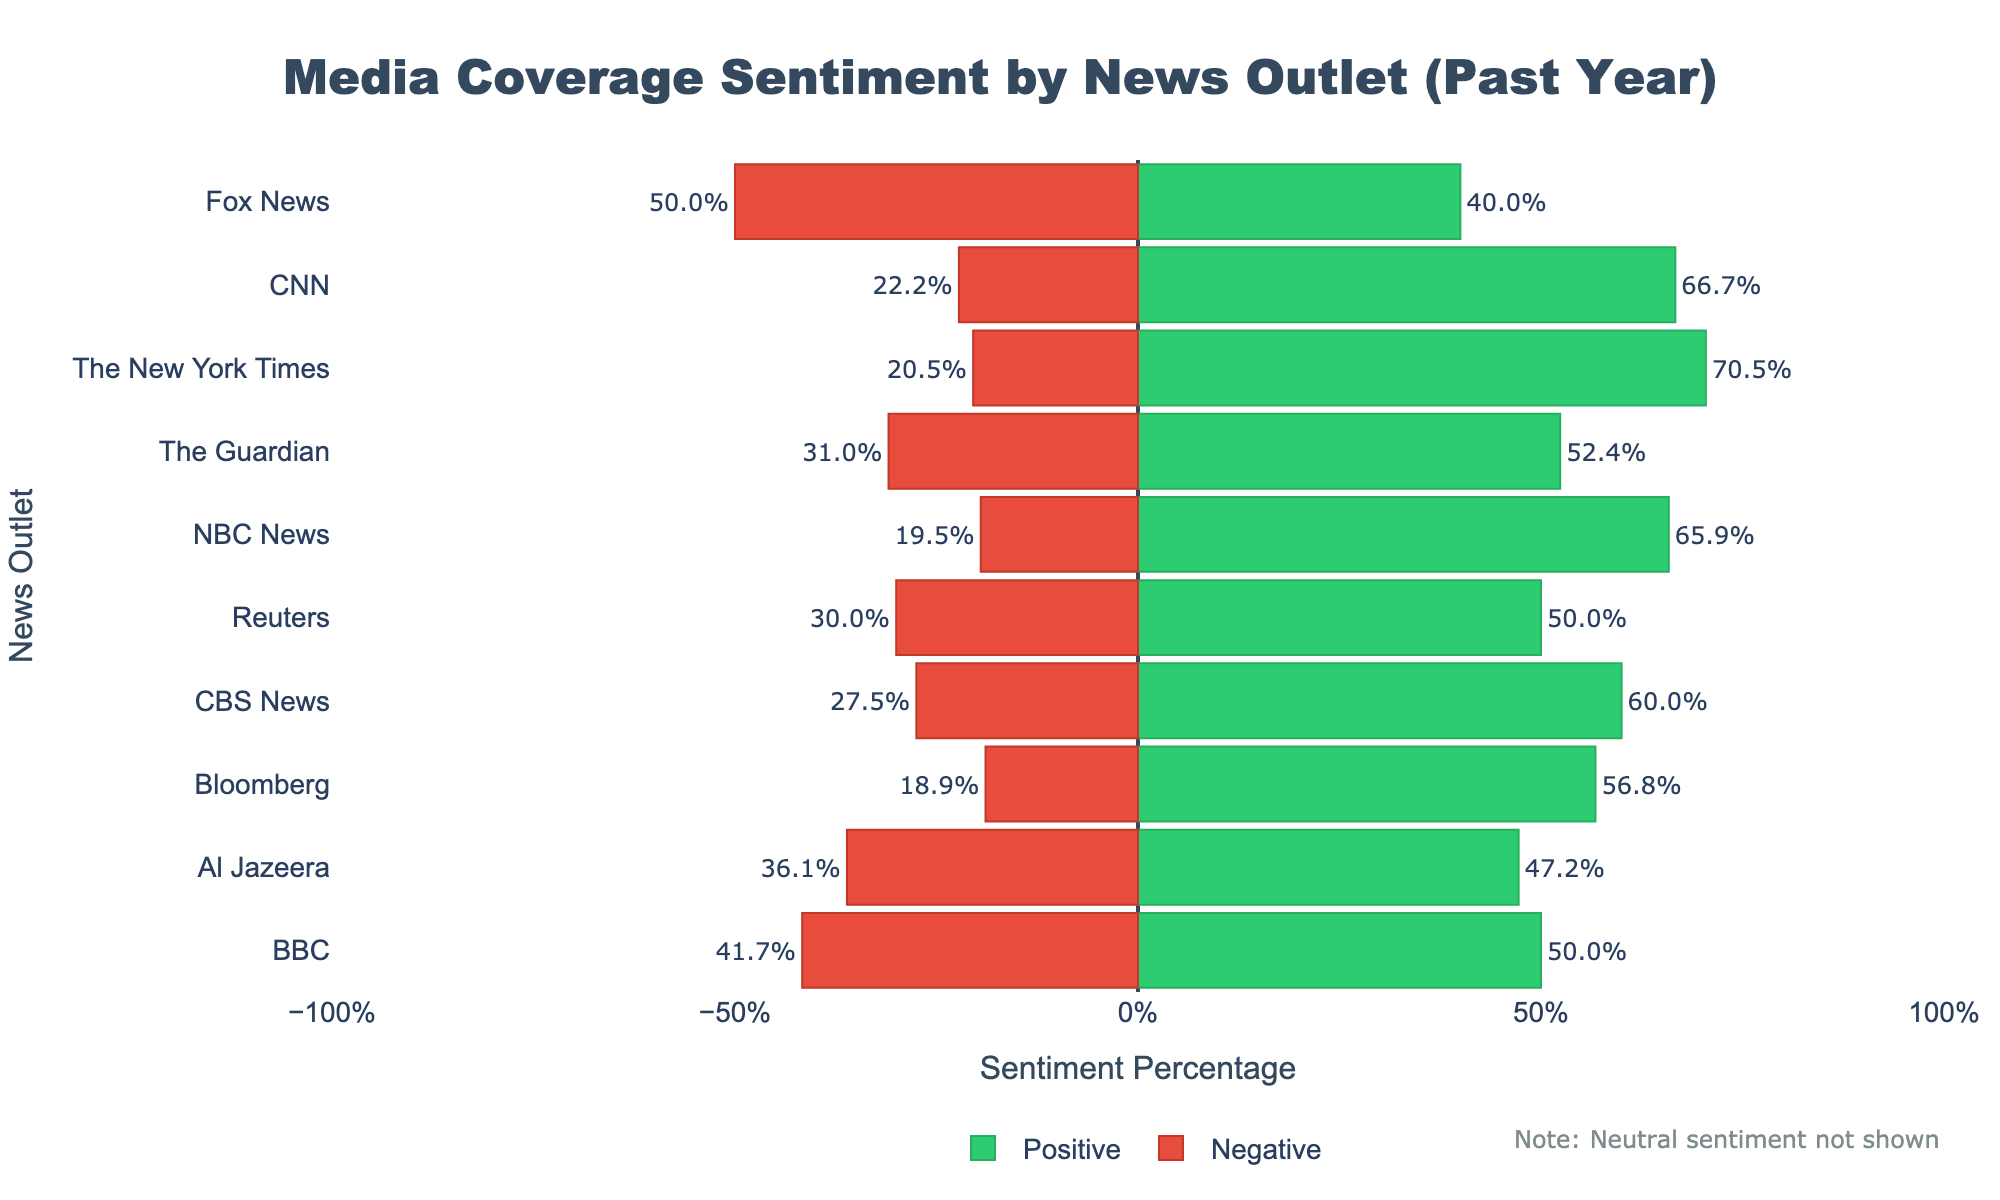Which news outlet has the highest percentage of positive mentions? By observing the bar lengths colored in green, The New York Times has the longest green bar representing the highest percentage of positive mentions.
Answer: The New York Times Which news outlet has the highest percentage of negative mentions? By comparing the lengths of the red bars, Fox News has the longest red bar representing the highest percentage of negative mentions.
Answer: Fox News What is the difference in positive sentiment percentage between The New York Times and Fox News? The positive percentage for The New York Times is read from the chart as ~67.4%, and for Fox News, it is ~40.0%. The difference is 67.4% - 40.0% = 27.4%.
Answer: 27.4% Which news outlet has the smallest difference between positive and negative sentiment percentages? By estimating the lengths of green and red bars together, we see that BBC's bars are almost equal in length. Their difference in percentages is very small compared to other outlets.
Answer: BBC How many outlets have a negative sentiment percentage greater than 50%? Reviewing the figure, only Fox News has a red bar (negative percentage) extending beyond the midpoint (50% mark). Therefore, only one outlet has a negative sentiment percentage over 50%.
Answer: 1 Compare the positive sentiment for Bloomberg and NBC News. Which one is greater and by how much? Bloomberg's positive sentiment percentage is ~60%, while NBC News's percentage is ~77.1%. The difference is ~77.1% - ~60% = ~17.1%.
Answer: NBC News by ~17.1% Which two news outlets have the closest positive sentiment percentages? By observing the green bar lengths visually, CNN (with ~63.8%) and CBS News (with ~63.2%) appear to have almost the same lengths and thus the closest positive sentiment percentages.
Answer: CNN and CBS News How does Al Jazeera's positive sentiment percentage compare to its negative sentiment percentage? Looking at the green and red bars for Al Jazeera, the positive sentiment occupies ~52.8% while the negative sentiment is ~40.4%. Thus, the positive sentiment is higher.
Answer: Positive sentiment is higher What is the average positive sentiment percentage across all news outlets? Summing all the positive sentiment percentages: 300/450, 200/500, 180/360, 220/420, 310/440, 170/360, 270/410, 240/400, 200/400, 210/370 then dividing by 10: (66.7%+40%+50%+52.4%+70.5%+47.2%+65.9%+60%+50%+56.8%)/10 ≈ 55.9%.
Answer: ~55.9% Which news outlet has the highest neutral sentiment mentions? The neutral sentiment is noted as excluded but by comparison of the smaller, light-text annotations on each bar, Bloomberg has the most mentions (90).
Answer: Bloomberg 